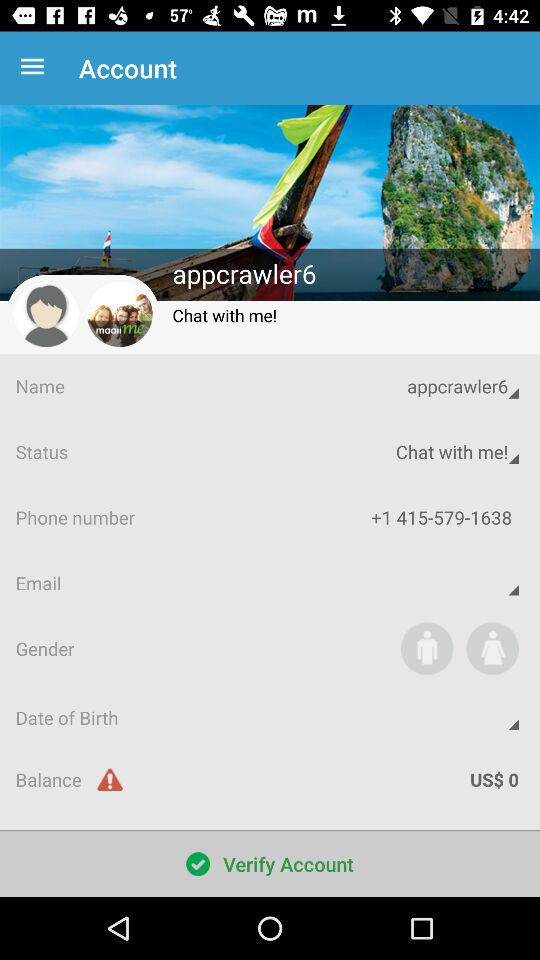What is the username? The username is "appcrawler6". 